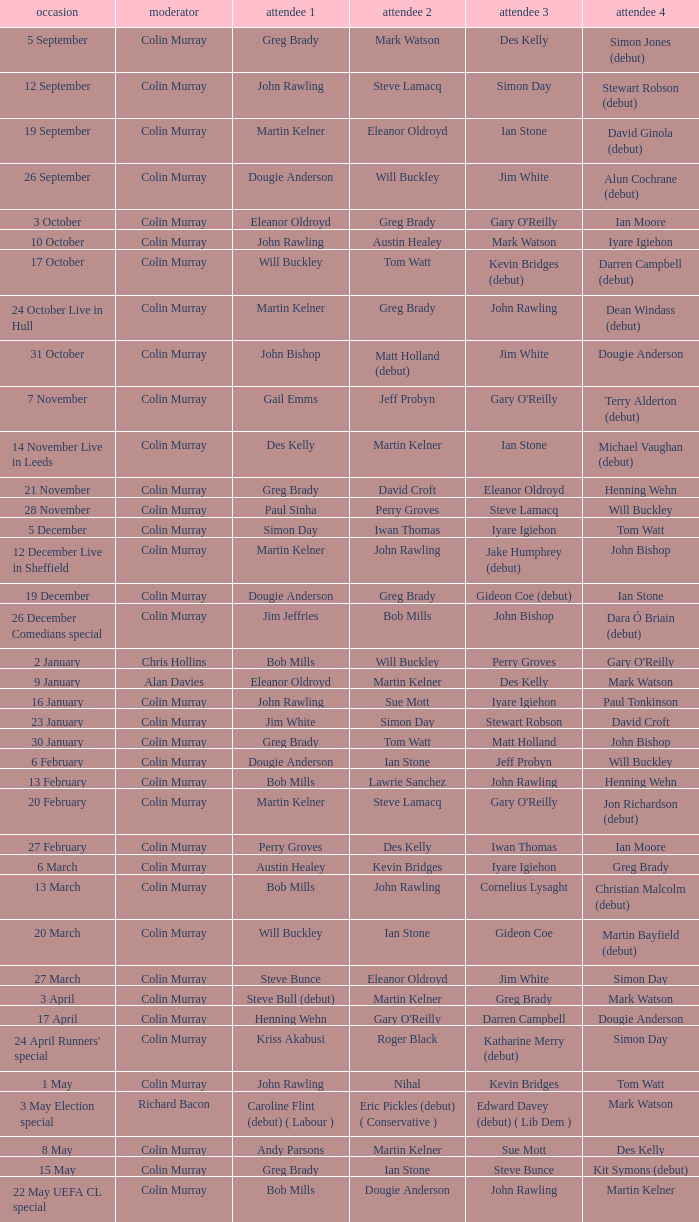Could you help me parse every detail presented in this table? {'header': ['occasion', 'moderator', 'attendee 1', 'attendee 2', 'attendee 3', 'attendee 4'], 'rows': [['5 September', 'Colin Murray', 'Greg Brady', 'Mark Watson', 'Des Kelly', 'Simon Jones (debut)'], ['12 September', 'Colin Murray', 'John Rawling', 'Steve Lamacq', 'Simon Day', 'Stewart Robson (debut)'], ['19 September', 'Colin Murray', 'Martin Kelner', 'Eleanor Oldroyd', 'Ian Stone', 'David Ginola (debut)'], ['26 September', 'Colin Murray', 'Dougie Anderson', 'Will Buckley', 'Jim White', 'Alun Cochrane (debut)'], ['3 October', 'Colin Murray', 'Eleanor Oldroyd', 'Greg Brady', "Gary O'Reilly", 'Ian Moore'], ['10 October', 'Colin Murray', 'John Rawling', 'Austin Healey', 'Mark Watson', 'Iyare Igiehon'], ['17 October', 'Colin Murray', 'Will Buckley', 'Tom Watt', 'Kevin Bridges (debut)', 'Darren Campbell (debut)'], ['24 October Live in Hull', 'Colin Murray', 'Martin Kelner', 'Greg Brady', 'John Rawling', 'Dean Windass (debut)'], ['31 October', 'Colin Murray', 'John Bishop', 'Matt Holland (debut)', 'Jim White', 'Dougie Anderson'], ['7 November', 'Colin Murray', 'Gail Emms', 'Jeff Probyn', "Gary O'Reilly", 'Terry Alderton (debut)'], ['14 November Live in Leeds', 'Colin Murray', 'Des Kelly', 'Martin Kelner', 'Ian Stone', 'Michael Vaughan (debut)'], ['21 November', 'Colin Murray', 'Greg Brady', 'David Croft', 'Eleanor Oldroyd', 'Henning Wehn'], ['28 November', 'Colin Murray', 'Paul Sinha', 'Perry Groves', 'Steve Lamacq', 'Will Buckley'], ['5 December', 'Colin Murray', 'Simon Day', 'Iwan Thomas', 'Iyare Igiehon', 'Tom Watt'], ['12 December Live in Sheffield', 'Colin Murray', 'Martin Kelner', 'John Rawling', 'Jake Humphrey (debut)', 'John Bishop'], ['19 December', 'Colin Murray', 'Dougie Anderson', 'Greg Brady', 'Gideon Coe (debut)', 'Ian Stone'], ['26 December Comedians special', 'Colin Murray', 'Jim Jeffries', 'Bob Mills', 'John Bishop', 'Dara Ó Briain (debut)'], ['2 January', 'Chris Hollins', 'Bob Mills', 'Will Buckley', 'Perry Groves', "Gary O'Reilly"], ['9 January', 'Alan Davies', 'Eleanor Oldroyd', 'Martin Kelner', 'Des Kelly', 'Mark Watson'], ['16 January', 'Colin Murray', 'John Rawling', 'Sue Mott', 'Iyare Igiehon', 'Paul Tonkinson'], ['23 January', 'Colin Murray', 'Jim White', 'Simon Day', 'Stewart Robson', 'David Croft'], ['30 January', 'Colin Murray', 'Greg Brady', 'Tom Watt', 'Matt Holland', 'John Bishop'], ['6 February', 'Colin Murray', 'Dougie Anderson', 'Ian Stone', 'Jeff Probyn', 'Will Buckley'], ['13 February', 'Colin Murray', 'Bob Mills', 'Lawrie Sanchez', 'John Rawling', 'Henning Wehn'], ['20 February', 'Colin Murray', 'Martin Kelner', 'Steve Lamacq', "Gary O'Reilly", 'Jon Richardson (debut)'], ['27 February', 'Colin Murray', 'Perry Groves', 'Des Kelly', 'Iwan Thomas', 'Ian Moore'], ['6 March', 'Colin Murray', 'Austin Healey', 'Kevin Bridges', 'Iyare Igiehon', 'Greg Brady'], ['13 March', 'Colin Murray', 'Bob Mills', 'John Rawling', 'Cornelius Lysaght', 'Christian Malcolm (debut)'], ['20 March', 'Colin Murray', 'Will Buckley', 'Ian Stone', 'Gideon Coe', 'Martin Bayfield (debut)'], ['27 March', 'Colin Murray', 'Steve Bunce', 'Eleanor Oldroyd', 'Jim White', 'Simon Day'], ['3 April', 'Colin Murray', 'Steve Bull (debut)', 'Martin Kelner', 'Greg Brady', 'Mark Watson'], ['17 April', 'Colin Murray', 'Henning Wehn', "Gary O'Reilly", 'Darren Campbell', 'Dougie Anderson'], ["24 April Runners' special", 'Colin Murray', 'Kriss Akabusi', 'Roger Black', 'Katharine Merry (debut)', 'Simon Day'], ['1 May', 'Colin Murray', 'John Rawling', 'Nihal', 'Kevin Bridges', 'Tom Watt'], ['3 May Election special', 'Richard Bacon', 'Caroline Flint (debut) ( Labour )', 'Eric Pickles (debut) ( Conservative )', 'Edward Davey (debut) ( Lib Dem )', 'Mark Watson'], ['8 May', 'Colin Murray', 'Andy Parsons', 'Martin Kelner', 'Sue Mott', 'Des Kelly'], ['15 May', 'Colin Murray', 'Greg Brady', 'Ian Stone', 'Steve Bunce', 'Kit Symons (debut)'], ['22 May UEFA CL special', 'Colin Murray', 'Bob Mills', 'Dougie Anderson', 'John Rawling', 'Martin Kelner']]} On episodes where guest 1 is Jim White, who was guest 3? Stewart Robson. 